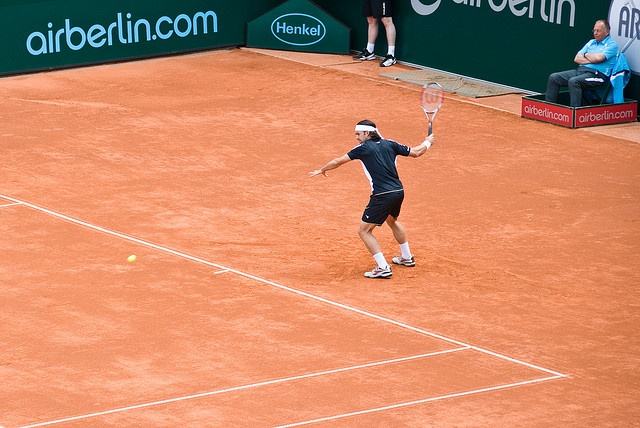Describe the objects in this image and their specific colors. I can see people in black, lightgray, lightpink, and navy tones, people in black, darkblue, blue, and lightblue tones, people in black, darkgray, pink, and lavender tones, chair in black, lightblue, and navy tones, and tennis racket in black, lightpink, salmon, and darkgray tones in this image. 